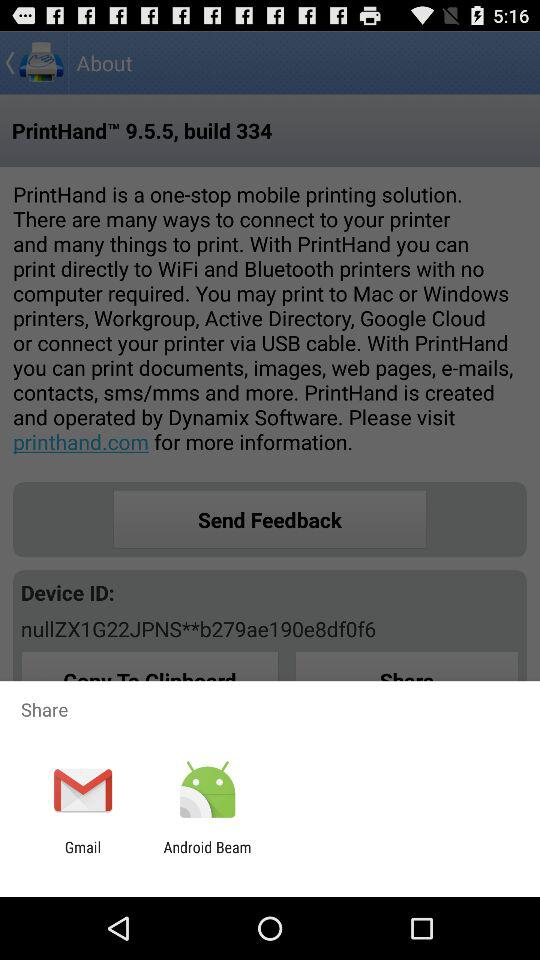What are the available sharing options? The available sharing options are "Gmail" and "Android Beam". 